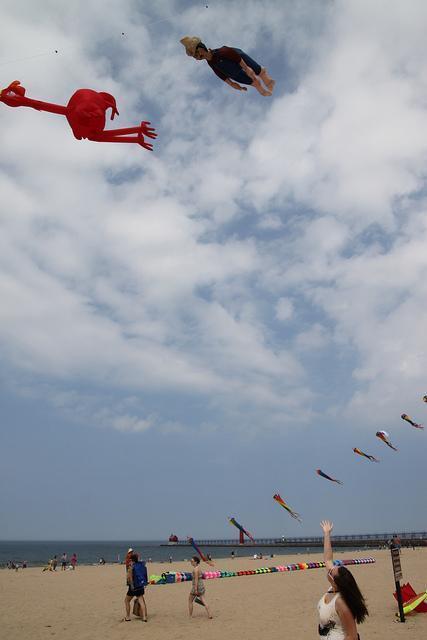How many kites are flying?
Give a very brief answer. 2. How many kites are in the photo?
Give a very brief answer. 2. 